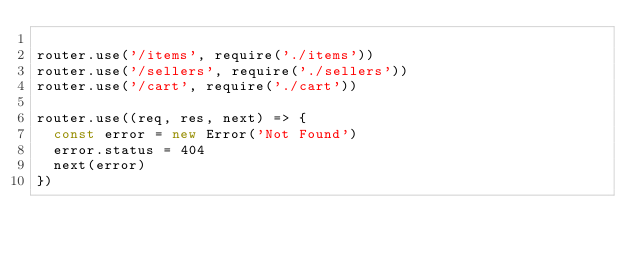<code> <loc_0><loc_0><loc_500><loc_500><_JavaScript_>
router.use('/items', require('./items'))
router.use('/sellers', require('./sellers'))
router.use('/cart', require('./cart'))

router.use((req, res, next) => {
  const error = new Error('Not Found')
  error.status = 404
  next(error)
})
</code> 